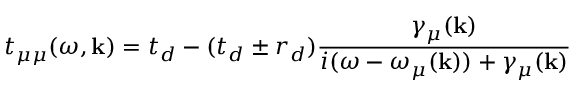Convert formula to latex. <formula><loc_0><loc_0><loc_500><loc_500>t _ { \mu \mu } ( \omega , k ) = t _ { d } - ( t _ { d } \pm r _ { d } ) \frac { \gamma _ { \mu } ( k ) } { i ( \omega - \omega _ { \mu } ( k ) ) + \gamma _ { \mu } ( k ) }</formula> 